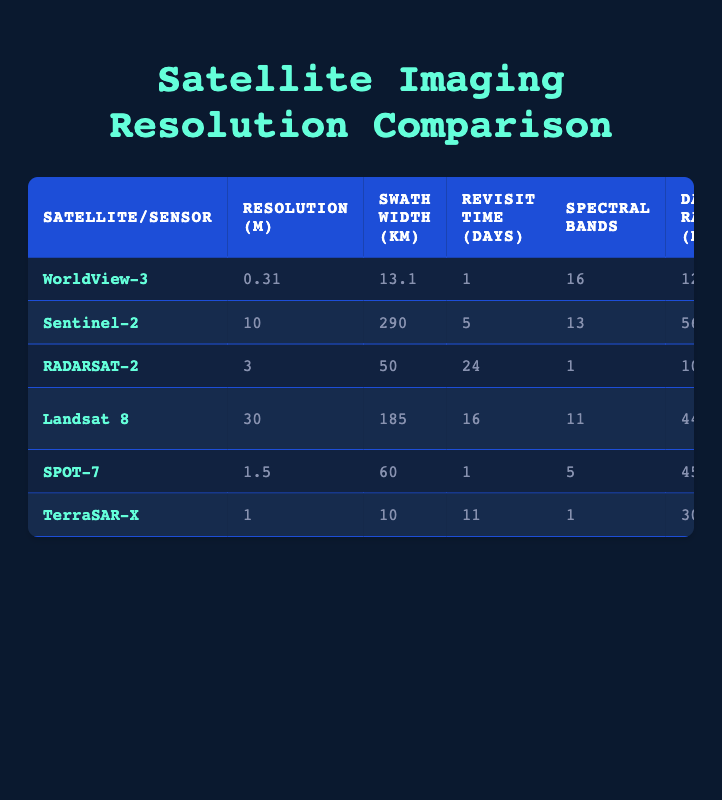What is the resolution of WorldView-3? The table lists WorldView-3 under "Satellite/Sensor" and indicates a resolution of 0.31 meters in the corresponding column.
Answer: 0.31 m Which satellite has the highest image quality in PSNR? By examining the "Image Quality (PSNR)" column, WorldView-3 shows the highest PSNR value of 42, making it the satellite with the best image quality.
Answer: WorldView-3 What is the average resolution of the satellites mentioned? The resolutions for the satellites are 0.31, 10, 3, 30, 1.5, and 1 meters. Adding these values gives a total of 45.81 meters and dividing by 6 (the number of satellites) yields an average of 7.63 meters.
Answer: 7.63 m Is RADARSAT-2 capable of night imaging? The table shows that RADARSAT-2 has "Yes" in the "Night Imaging Capability" column, indicating that it can perform imaging at night.
Answer: Yes Which satellite has the largest swath width? The swath widths are 13.1, 290, 50, 185, 60, and 10 km. The largest value, found under the "Swath Width (km)" column for Sentinel-2, is 290 km.
Answer: Sentinel-2 What is the total data rate of the satellites that can penetrate clouds? The relevant satellites are RADARSAT-2 and TerraSAR-X, which have data rates of 105 and 300 Mbps, respectively. Summing these gives 405 Mbps as the total data rate for cloud-penetrating satellites.
Answer: 405 Mbps Which satellite has a lower price per square kilometer, Landsat 8 or Sentinel-2? The price per square kilometer for Sentinel-2 is $0 and for Landsat 8 is also $0. Therefore, both satellites have the same price, making it impossible to deem one lower than the other.
Answer: Same price What is the difference in revisit time between WorldView-3 and SPOT-7? WorldView-3 has a revisit time of 1 day, while SPOT-7 has a revisit time of 1 day as well. This means there is no difference in revisit time between these two satellites.
Answer: 0 days What is the total number of spectral bands for all satellites combined? The number of spectral bands are 16, 13, 1, 11, 5, and 1. Adding these together results in a total of 47 spectral bands across all satellites.
Answer: 47 Which satellite is the best choice for data regarding cloud penetration and night imaging? Based on the table, RADARSAT-2 has high cloud penetration and night imaging capabilities, making it the better choice in this context.
Answer: RADARSAT-2 